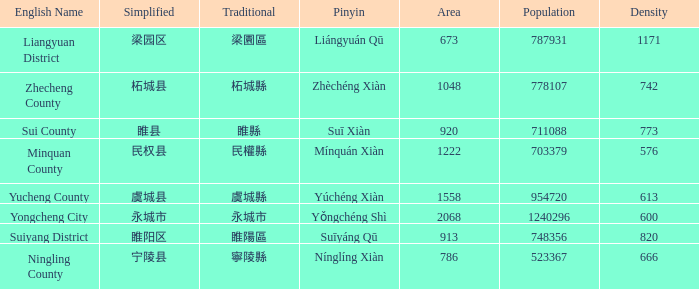How many areas have a population of 703379? 1.0. 